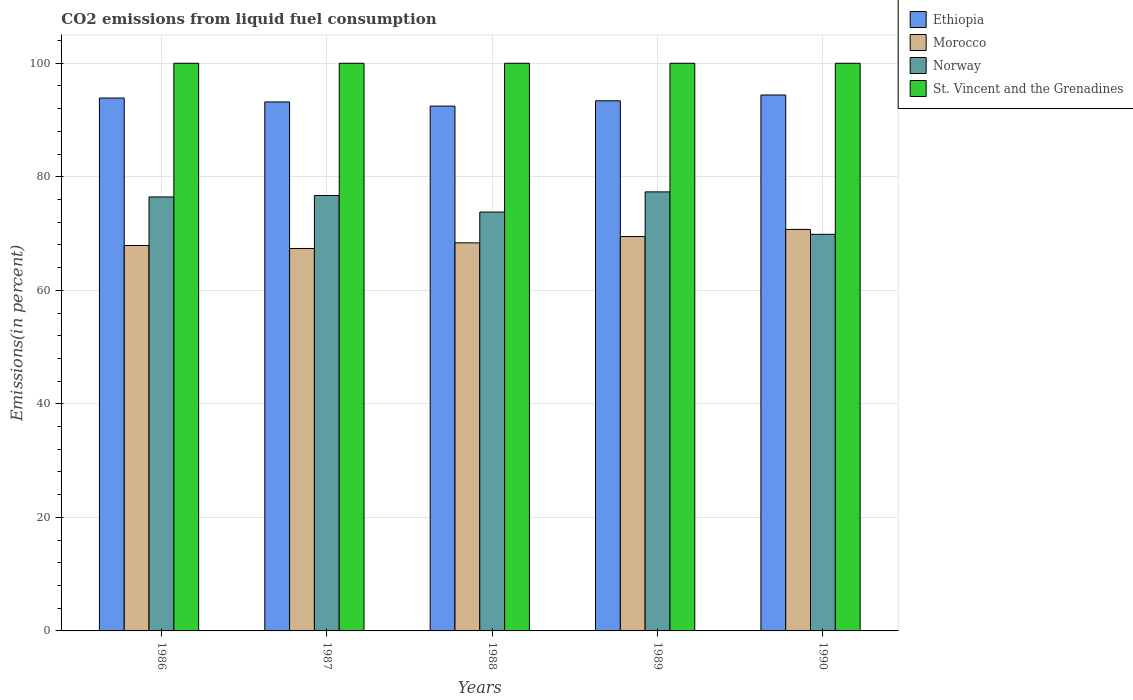How many different coloured bars are there?
Provide a short and direct response. 4. How many groups of bars are there?
Your answer should be very brief. 5. Are the number of bars per tick equal to the number of legend labels?
Ensure brevity in your answer.  Yes. Are the number of bars on each tick of the X-axis equal?
Offer a terse response. Yes. How many bars are there on the 3rd tick from the left?
Give a very brief answer. 4. How many bars are there on the 4th tick from the right?
Your answer should be compact. 4. What is the label of the 5th group of bars from the left?
Keep it short and to the point. 1990. In how many cases, is the number of bars for a given year not equal to the number of legend labels?
Offer a very short reply. 0. What is the total CO2 emitted in St. Vincent and the Grenadines in 1990?
Give a very brief answer. 100. Across all years, what is the maximum total CO2 emitted in St. Vincent and the Grenadines?
Provide a succinct answer. 100. Across all years, what is the minimum total CO2 emitted in Ethiopia?
Make the answer very short. 92.46. What is the total total CO2 emitted in Norway in the graph?
Give a very brief answer. 374.15. What is the difference between the total CO2 emitted in Norway in 1989 and that in 1990?
Your answer should be very brief. 7.47. What is the difference between the total CO2 emitted in Ethiopia in 1986 and the total CO2 emitted in Norway in 1988?
Offer a very short reply. 20.09. What is the average total CO2 emitted in Morocco per year?
Ensure brevity in your answer.  68.77. In the year 1987, what is the difference between the total CO2 emitted in Ethiopia and total CO2 emitted in Norway?
Your answer should be compact. 16.48. In how many years, is the total CO2 emitted in Morocco greater than 52 %?
Your response must be concise. 5. What is the ratio of the total CO2 emitted in Ethiopia in 1988 to that in 1990?
Provide a succinct answer. 0.98. Is the total CO2 emitted in Norway in 1987 less than that in 1988?
Provide a succinct answer. No. What is the difference between the highest and the second highest total CO2 emitted in Norway?
Make the answer very short. 0.64. What is the difference between the highest and the lowest total CO2 emitted in Norway?
Ensure brevity in your answer.  7.47. Is it the case that in every year, the sum of the total CO2 emitted in St. Vincent and the Grenadines and total CO2 emitted in Morocco is greater than the sum of total CO2 emitted in Ethiopia and total CO2 emitted in Norway?
Ensure brevity in your answer.  Yes. What does the 2nd bar from the left in 1988 represents?
Keep it short and to the point. Morocco. Is it the case that in every year, the sum of the total CO2 emitted in Ethiopia and total CO2 emitted in Norway is greater than the total CO2 emitted in St. Vincent and the Grenadines?
Offer a terse response. Yes. How many bars are there?
Offer a terse response. 20. Are all the bars in the graph horizontal?
Make the answer very short. No. How many years are there in the graph?
Give a very brief answer. 5. Does the graph contain grids?
Your response must be concise. Yes. How many legend labels are there?
Your answer should be very brief. 4. How are the legend labels stacked?
Give a very brief answer. Vertical. What is the title of the graph?
Your answer should be compact. CO2 emissions from liquid fuel consumption. What is the label or title of the Y-axis?
Ensure brevity in your answer.  Emissions(in percent). What is the Emissions(in percent) of Ethiopia in 1986?
Keep it short and to the point. 93.87. What is the Emissions(in percent) in Morocco in 1986?
Your answer should be very brief. 67.9. What is the Emissions(in percent) in Norway in 1986?
Your response must be concise. 76.45. What is the Emissions(in percent) of St. Vincent and the Grenadines in 1986?
Keep it short and to the point. 100. What is the Emissions(in percent) of Ethiopia in 1987?
Offer a very short reply. 93.18. What is the Emissions(in percent) of Morocco in 1987?
Offer a very short reply. 67.37. What is the Emissions(in percent) in Norway in 1987?
Provide a succinct answer. 76.7. What is the Emissions(in percent) of St. Vincent and the Grenadines in 1987?
Provide a short and direct response. 100. What is the Emissions(in percent) of Ethiopia in 1988?
Provide a short and direct response. 92.46. What is the Emissions(in percent) in Morocco in 1988?
Offer a very short reply. 68.36. What is the Emissions(in percent) of Norway in 1988?
Ensure brevity in your answer.  73.79. What is the Emissions(in percent) in St. Vincent and the Grenadines in 1988?
Offer a very short reply. 100. What is the Emissions(in percent) of Ethiopia in 1989?
Your answer should be compact. 93.39. What is the Emissions(in percent) of Morocco in 1989?
Your answer should be compact. 69.47. What is the Emissions(in percent) of Norway in 1989?
Give a very brief answer. 77.34. What is the Emissions(in percent) in St. Vincent and the Grenadines in 1989?
Keep it short and to the point. 100. What is the Emissions(in percent) of Ethiopia in 1990?
Your response must be concise. 94.41. What is the Emissions(in percent) in Morocco in 1990?
Provide a short and direct response. 70.73. What is the Emissions(in percent) of Norway in 1990?
Ensure brevity in your answer.  69.87. Across all years, what is the maximum Emissions(in percent) in Ethiopia?
Offer a terse response. 94.41. Across all years, what is the maximum Emissions(in percent) in Morocco?
Keep it short and to the point. 70.73. Across all years, what is the maximum Emissions(in percent) of Norway?
Provide a short and direct response. 77.34. Across all years, what is the maximum Emissions(in percent) of St. Vincent and the Grenadines?
Your answer should be compact. 100. Across all years, what is the minimum Emissions(in percent) of Ethiopia?
Your response must be concise. 92.46. Across all years, what is the minimum Emissions(in percent) of Morocco?
Your answer should be compact. 67.37. Across all years, what is the minimum Emissions(in percent) in Norway?
Give a very brief answer. 69.87. What is the total Emissions(in percent) in Ethiopia in the graph?
Provide a succinct answer. 467.31. What is the total Emissions(in percent) of Morocco in the graph?
Your response must be concise. 343.84. What is the total Emissions(in percent) in Norway in the graph?
Ensure brevity in your answer.  374.15. What is the difference between the Emissions(in percent) of Ethiopia in 1986 and that in 1987?
Make the answer very short. 0.69. What is the difference between the Emissions(in percent) in Morocco in 1986 and that in 1987?
Provide a short and direct response. 0.53. What is the difference between the Emissions(in percent) of Norway in 1986 and that in 1987?
Keep it short and to the point. -0.25. What is the difference between the Emissions(in percent) of St. Vincent and the Grenadines in 1986 and that in 1987?
Provide a succinct answer. 0. What is the difference between the Emissions(in percent) of Ethiopia in 1986 and that in 1988?
Offer a very short reply. 1.42. What is the difference between the Emissions(in percent) in Morocco in 1986 and that in 1988?
Provide a short and direct response. -0.47. What is the difference between the Emissions(in percent) of Norway in 1986 and that in 1988?
Give a very brief answer. 2.66. What is the difference between the Emissions(in percent) of Ethiopia in 1986 and that in 1989?
Make the answer very short. 0.49. What is the difference between the Emissions(in percent) of Morocco in 1986 and that in 1989?
Give a very brief answer. -1.58. What is the difference between the Emissions(in percent) of Norway in 1986 and that in 1989?
Make the answer very short. -0.89. What is the difference between the Emissions(in percent) in St. Vincent and the Grenadines in 1986 and that in 1989?
Make the answer very short. 0. What is the difference between the Emissions(in percent) in Ethiopia in 1986 and that in 1990?
Make the answer very short. -0.54. What is the difference between the Emissions(in percent) of Morocco in 1986 and that in 1990?
Offer a terse response. -2.84. What is the difference between the Emissions(in percent) of Norway in 1986 and that in 1990?
Keep it short and to the point. 6.58. What is the difference between the Emissions(in percent) in Ethiopia in 1987 and that in 1988?
Offer a terse response. 0.73. What is the difference between the Emissions(in percent) in Morocco in 1987 and that in 1988?
Offer a very short reply. -0.99. What is the difference between the Emissions(in percent) in Norway in 1987 and that in 1988?
Give a very brief answer. 2.91. What is the difference between the Emissions(in percent) in St. Vincent and the Grenadines in 1987 and that in 1988?
Make the answer very short. 0. What is the difference between the Emissions(in percent) in Ethiopia in 1987 and that in 1989?
Ensure brevity in your answer.  -0.2. What is the difference between the Emissions(in percent) of Morocco in 1987 and that in 1989?
Your response must be concise. -2.1. What is the difference between the Emissions(in percent) of Norway in 1987 and that in 1989?
Keep it short and to the point. -0.64. What is the difference between the Emissions(in percent) of St. Vincent and the Grenadines in 1987 and that in 1989?
Provide a succinct answer. 0. What is the difference between the Emissions(in percent) in Ethiopia in 1987 and that in 1990?
Keep it short and to the point. -1.23. What is the difference between the Emissions(in percent) of Morocco in 1987 and that in 1990?
Your answer should be very brief. -3.36. What is the difference between the Emissions(in percent) in Norway in 1987 and that in 1990?
Offer a very short reply. 6.83. What is the difference between the Emissions(in percent) in St. Vincent and the Grenadines in 1987 and that in 1990?
Offer a very short reply. 0. What is the difference between the Emissions(in percent) of Ethiopia in 1988 and that in 1989?
Your answer should be very brief. -0.93. What is the difference between the Emissions(in percent) of Morocco in 1988 and that in 1989?
Provide a short and direct response. -1.11. What is the difference between the Emissions(in percent) of Norway in 1988 and that in 1989?
Your answer should be very brief. -3.55. What is the difference between the Emissions(in percent) in St. Vincent and the Grenadines in 1988 and that in 1989?
Provide a succinct answer. 0. What is the difference between the Emissions(in percent) of Ethiopia in 1988 and that in 1990?
Your response must be concise. -1.96. What is the difference between the Emissions(in percent) in Morocco in 1988 and that in 1990?
Keep it short and to the point. -2.37. What is the difference between the Emissions(in percent) of Norway in 1988 and that in 1990?
Give a very brief answer. 3.92. What is the difference between the Emissions(in percent) in Ethiopia in 1989 and that in 1990?
Offer a very short reply. -1.03. What is the difference between the Emissions(in percent) of Morocco in 1989 and that in 1990?
Offer a terse response. -1.26. What is the difference between the Emissions(in percent) in Norway in 1989 and that in 1990?
Your response must be concise. 7.47. What is the difference between the Emissions(in percent) of Ethiopia in 1986 and the Emissions(in percent) of Morocco in 1987?
Keep it short and to the point. 26.5. What is the difference between the Emissions(in percent) in Ethiopia in 1986 and the Emissions(in percent) in Norway in 1987?
Offer a very short reply. 17.17. What is the difference between the Emissions(in percent) of Ethiopia in 1986 and the Emissions(in percent) of St. Vincent and the Grenadines in 1987?
Provide a short and direct response. -6.13. What is the difference between the Emissions(in percent) of Morocco in 1986 and the Emissions(in percent) of Norway in 1987?
Provide a succinct answer. -8.8. What is the difference between the Emissions(in percent) of Morocco in 1986 and the Emissions(in percent) of St. Vincent and the Grenadines in 1987?
Your answer should be compact. -32.1. What is the difference between the Emissions(in percent) in Norway in 1986 and the Emissions(in percent) in St. Vincent and the Grenadines in 1987?
Provide a short and direct response. -23.55. What is the difference between the Emissions(in percent) in Ethiopia in 1986 and the Emissions(in percent) in Morocco in 1988?
Offer a terse response. 25.51. What is the difference between the Emissions(in percent) in Ethiopia in 1986 and the Emissions(in percent) in Norway in 1988?
Ensure brevity in your answer.  20.09. What is the difference between the Emissions(in percent) of Ethiopia in 1986 and the Emissions(in percent) of St. Vincent and the Grenadines in 1988?
Offer a very short reply. -6.13. What is the difference between the Emissions(in percent) of Morocco in 1986 and the Emissions(in percent) of Norway in 1988?
Your answer should be very brief. -5.89. What is the difference between the Emissions(in percent) of Morocco in 1986 and the Emissions(in percent) of St. Vincent and the Grenadines in 1988?
Provide a short and direct response. -32.1. What is the difference between the Emissions(in percent) in Norway in 1986 and the Emissions(in percent) in St. Vincent and the Grenadines in 1988?
Make the answer very short. -23.55. What is the difference between the Emissions(in percent) of Ethiopia in 1986 and the Emissions(in percent) of Morocco in 1989?
Provide a succinct answer. 24.4. What is the difference between the Emissions(in percent) in Ethiopia in 1986 and the Emissions(in percent) in Norway in 1989?
Your answer should be very brief. 16.53. What is the difference between the Emissions(in percent) of Ethiopia in 1986 and the Emissions(in percent) of St. Vincent and the Grenadines in 1989?
Provide a short and direct response. -6.13. What is the difference between the Emissions(in percent) of Morocco in 1986 and the Emissions(in percent) of Norway in 1989?
Make the answer very short. -9.44. What is the difference between the Emissions(in percent) of Morocco in 1986 and the Emissions(in percent) of St. Vincent and the Grenadines in 1989?
Your answer should be compact. -32.1. What is the difference between the Emissions(in percent) of Norway in 1986 and the Emissions(in percent) of St. Vincent and the Grenadines in 1989?
Your answer should be very brief. -23.55. What is the difference between the Emissions(in percent) in Ethiopia in 1986 and the Emissions(in percent) in Morocco in 1990?
Your answer should be very brief. 23.14. What is the difference between the Emissions(in percent) of Ethiopia in 1986 and the Emissions(in percent) of Norway in 1990?
Ensure brevity in your answer.  24.01. What is the difference between the Emissions(in percent) of Ethiopia in 1986 and the Emissions(in percent) of St. Vincent and the Grenadines in 1990?
Offer a terse response. -6.13. What is the difference between the Emissions(in percent) in Morocco in 1986 and the Emissions(in percent) in Norway in 1990?
Provide a succinct answer. -1.97. What is the difference between the Emissions(in percent) of Morocco in 1986 and the Emissions(in percent) of St. Vincent and the Grenadines in 1990?
Your response must be concise. -32.1. What is the difference between the Emissions(in percent) of Norway in 1986 and the Emissions(in percent) of St. Vincent and the Grenadines in 1990?
Offer a very short reply. -23.55. What is the difference between the Emissions(in percent) in Ethiopia in 1987 and the Emissions(in percent) in Morocco in 1988?
Your response must be concise. 24.82. What is the difference between the Emissions(in percent) of Ethiopia in 1987 and the Emissions(in percent) of Norway in 1988?
Your answer should be very brief. 19.39. What is the difference between the Emissions(in percent) of Ethiopia in 1987 and the Emissions(in percent) of St. Vincent and the Grenadines in 1988?
Your answer should be compact. -6.82. What is the difference between the Emissions(in percent) in Morocco in 1987 and the Emissions(in percent) in Norway in 1988?
Provide a succinct answer. -6.42. What is the difference between the Emissions(in percent) in Morocco in 1987 and the Emissions(in percent) in St. Vincent and the Grenadines in 1988?
Make the answer very short. -32.63. What is the difference between the Emissions(in percent) in Norway in 1987 and the Emissions(in percent) in St. Vincent and the Grenadines in 1988?
Provide a short and direct response. -23.3. What is the difference between the Emissions(in percent) in Ethiopia in 1987 and the Emissions(in percent) in Morocco in 1989?
Keep it short and to the point. 23.71. What is the difference between the Emissions(in percent) of Ethiopia in 1987 and the Emissions(in percent) of Norway in 1989?
Make the answer very short. 15.84. What is the difference between the Emissions(in percent) of Ethiopia in 1987 and the Emissions(in percent) of St. Vincent and the Grenadines in 1989?
Your answer should be compact. -6.82. What is the difference between the Emissions(in percent) of Morocco in 1987 and the Emissions(in percent) of Norway in 1989?
Provide a succinct answer. -9.97. What is the difference between the Emissions(in percent) of Morocco in 1987 and the Emissions(in percent) of St. Vincent and the Grenadines in 1989?
Your answer should be very brief. -32.63. What is the difference between the Emissions(in percent) of Norway in 1987 and the Emissions(in percent) of St. Vincent and the Grenadines in 1989?
Your answer should be compact. -23.3. What is the difference between the Emissions(in percent) in Ethiopia in 1987 and the Emissions(in percent) in Morocco in 1990?
Ensure brevity in your answer.  22.45. What is the difference between the Emissions(in percent) of Ethiopia in 1987 and the Emissions(in percent) of Norway in 1990?
Your response must be concise. 23.31. What is the difference between the Emissions(in percent) of Ethiopia in 1987 and the Emissions(in percent) of St. Vincent and the Grenadines in 1990?
Give a very brief answer. -6.82. What is the difference between the Emissions(in percent) in Morocco in 1987 and the Emissions(in percent) in Norway in 1990?
Your answer should be compact. -2.5. What is the difference between the Emissions(in percent) of Morocco in 1987 and the Emissions(in percent) of St. Vincent and the Grenadines in 1990?
Keep it short and to the point. -32.63. What is the difference between the Emissions(in percent) of Norway in 1987 and the Emissions(in percent) of St. Vincent and the Grenadines in 1990?
Make the answer very short. -23.3. What is the difference between the Emissions(in percent) in Ethiopia in 1988 and the Emissions(in percent) in Morocco in 1989?
Give a very brief answer. 22.98. What is the difference between the Emissions(in percent) in Ethiopia in 1988 and the Emissions(in percent) in Norway in 1989?
Your response must be concise. 15.11. What is the difference between the Emissions(in percent) in Ethiopia in 1988 and the Emissions(in percent) in St. Vincent and the Grenadines in 1989?
Make the answer very short. -7.54. What is the difference between the Emissions(in percent) of Morocco in 1988 and the Emissions(in percent) of Norway in 1989?
Ensure brevity in your answer.  -8.98. What is the difference between the Emissions(in percent) of Morocco in 1988 and the Emissions(in percent) of St. Vincent and the Grenadines in 1989?
Your response must be concise. -31.64. What is the difference between the Emissions(in percent) in Norway in 1988 and the Emissions(in percent) in St. Vincent and the Grenadines in 1989?
Your response must be concise. -26.21. What is the difference between the Emissions(in percent) of Ethiopia in 1988 and the Emissions(in percent) of Morocco in 1990?
Keep it short and to the point. 21.72. What is the difference between the Emissions(in percent) of Ethiopia in 1988 and the Emissions(in percent) of Norway in 1990?
Ensure brevity in your answer.  22.59. What is the difference between the Emissions(in percent) of Ethiopia in 1988 and the Emissions(in percent) of St. Vincent and the Grenadines in 1990?
Ensure brevity in your answer.  -7.54. What is the difference between the Emissions(in percent) in Morocco in 1988 and the Emissions(in percent) in Norway in 1990?
Offer a very short reply. -1.5. What is the difference between the Emissions(in percent) in Morocco in 1988 and the Emissions(in percent) in St. Vincent and the Grenadines in 1990?
Your answer should be very brief. -31.64. What is the difference between the Emissions(in percent) in Norway in 1988 and the Emissions(in percent) in St. Vincent and the Grenadines in 1990?
Your answer should be very brief. -26.21. What is the difference between the Emissions(in percent) in Ethiopia in 1989 and the Emissions(in percent) in Morocco in 1990?
Keep it short and to the point. 22.65. What is the difference between the Emissions(in percent) of Ethiopia in 1989 and the Emissions(in percent) of Norway in 1990?
Give a very brief answer. 23.52. What is the difference between the Emissions(in percent) of Ethiopia in 1989 and the Emissions(in percent) of St. Vincent and the Grenadines in 1990?
Offer a very short reply. -6.61. What is the difference between the Emissions(in percent) of Morocco in 1989 and the Emissions(in percent) of Norway in 1990?
Keep it short and to the point. -0.4. What is the difference between the Emissions(in percent) in Morocco in 1989 and the Emissions(in percent) in St. Vincent and the Grenadines in 1990?
Your answer should be very brief. -30.53. What is the difference between the Emissions(in percent) of Norway in 1989 and the Emissions(in percent) of St. Vincent and the Grenadines in 1990?
Your response must be concise. -22.66. What is the average Emissions(in percent) of Ethiopia per year?
Offer a terse response. 93.46. What is the average Emissions(in percent) in Morocco per year?
Your answer should be very brief. 68.77. What is the average Emissions(in percent) of Norway per year?
Provide a succinct answer. 74.83. In the year 1986, what is the difference between the Emissions(in percent) in Ethiopia and Emissions(in percent) in Morocco?
Give a very brief answer. 25.98. In the year 1986, what is the difference between the Emissions(in percent) in Ethiopia and Emissions(in percent) in Norway?
Offer a terse response. 17.42. In the year 1986, what is the difference between the Emissions(in percent) of Ethiopia and Emissions(in percent) of St. Vincent and the Grenadines?
Your response must be concise. -6.13. In the year 1986, what is the difference between the Emissions(in percent) of Morocco and Emissions(in percent) of Norway?
Your answer should be compact. -8.55. In the year 1986, what is the difference between the Emissions(in percent) of Morocco and Emissions(in percent) of St. Vincent and the Grenadines?
Make the answer very short. -32.1. In the year 1986, what is the difference between the Emissions(in percent) of Norway and Emissions(in percent) of St. Vincent and the Grenadines?
Keep it short and to the point. -23.55. In the year 1987, what is the difference between the Emissions(in percent) in Ethiopia and Emissions(in percent) in Morocco?
Provide a succinct answer. 25.81. In the year 1987, what is the difference between the Emissions(in percent) in Ethiopia and Emissions(in percent) in Norway?
Give a very brief answer. 16.48. In the year 1987, what is the difference between the Emissions(in percent) of Ethiopia and Emissions(in percent) of St. Vincent and the Grenadines?
Make the answer very short. -6.82. In the year 1987, what is the difference between the Emissions(in percent) in Morocco and Emissions(in percent) in Norway?
Provide a short and direct response. -9.33. In the year 1987, what is the difference between the Emissions(in percent) of Morocco and Emissions(in percent) of St. Vincent and the Grenadines?
Make the answer very short. -32.63. In the year 1987, what is the difference between the Emissions(in percent) in Norway and Emissions(in percent) in St. Vincent and the Grenadines?
Your answer should be compact. -23.3. In the year 1988, what is the difference between the Emissions(in percent) of Ethiopia and Emissions(in percent) of Morocco?
Give a very brief answer. 24.09. In the year 1988, what is the difference between the Emissions(in percent) of Ethiopia and Emissions(in percent) of Norway?
Give a very brief answer. 18.67. In the year 1988, what is the difference between the Emissions(in percent) in Ethiopia and Emissions(in percent) in St. Vincent and the Grenadines?
Your response must be concise. -7.54. In the year 1988, what is the difference between the Emissions(in percent) in Morocco and Emissions(in percent) in Norway?
Make the answer very short. -5.42. In the year 1988, what is the difference between the Emissions(in percent) in Morocco and Emissions(in percent) in St. Vincent and the Grenadines?
Make the answer very short. -31.64. In the year 1988, what is the difference between the Emissions(in percent) of Norway and Emissions(in percent) of St. Vincent and the Grenadines?
Provide a short and direct response. -26.21. In the year 1989, what is the difference between the Emissions(in percent) of Ethiopia and Emissions(in percent) of Morocco?
Your response must be concise. 23.91. In the year 1989, what is the difference between the Emissions(in percent) in Ethiopia and Emissions(in percent) in Norway?
Your answer should be very brief. 16.04. In the year 1989, what is the difference between the Emissions(in percent) in Ethiopia and Emissions(in percent) in St. Vincent and the Grenadines?
Give a very brief answer. -6.61. In the year 1989, what is the difference between the Emissions(in percent) of Morocco and Emissions(in percent) of Norway?
Your answer should be compact. -7.87. In the year 1989, what is the difference between the Emissions(in percent) of Morocco and Emissions(in percent) of St. Vincent and the Grenadines?
Your response must be concise. -30.53. In the year 1989, what is the difference between the Emissions(in percent) in Norway and Emissions(in percent) in St. Vincent and the Grenadines?
Your response must be concise. -22.66. In the year 1990, what is the difference between the Emissions(in percent) in Ethiopia and Emissions(in percent) in Morocco?
Provide a short and direct response. 23.68. In the year 1990, what is the difference between the Emissions(in percent) in Ethiopia and Emissions(in percent) in Norway?
Your answer should be compact. 24.54. In the year 1990, what is the difference between the Emissions(in percent) in Ethiopia and Emissions(in percent) in St. Vincent and the Grenadines?
Provide a succinct answer. -5.59. In the year 1990, what is the difference between the Emissions(in percent) in Morocco and Emissions(in percent) in Norway?
Your answer should be compact. 0.86. In the year 1990, what is the difference between the Emissions(in percent) in Morocco and Emissions(in percent) in St. Vincent and the Grenadines?
Your answer should be compact. -29.27. In the year 1990, what is the difference between the Emissions(in percent) in Norway and Emissions(in percent) in St. Vincent and the Grenadines?
Make the answer very short. -30.13. What is the ratio of the Emissions(in percent) in Ethiopia in 1986 to that in 1987?
Offer a terse response. 1.01. What is the ratio of the Emissions(in percent) in Morocco in 1986 to that in 1987?
Offer a very short reply. 1.01. What is the ratio of the Emissions(in percent) of Norway in 1986 to that in 1987?
Offer a terse response. 1. What is the ratio of the Emissions(in percent) in St. Vincent and the Grenadines in 1986 to that in 1987?
Offer a terse response. 1. What is the ratio of the Emissions(in percent) of Ethiopia in 1986 to that in 1988?
Your answer should be very brief. 1.02. What is the ratio of the Emissions(in percent) of Morocco in 1986 to that in 1988?
Ensure brevity in your answer.  0.99. What is the ratio of the Emissions(in percent) in Norway in 1986 to that in 1988?
Your response must be concise. 1.04. What is the ratio of the Emissions(in percent) of Morocco in 1986 to that in 1989?
Make the answer very short. 0.98. What is the ratio of the Emissions(in percent) of Ethiopia in 1986 to that in 1990?
Offer a very short reply. 0.99. What is the ratio of the Emissions(in percent) in Morocco in 1986 to that in 1990?
Provide a succinct answer. 0.96. What is the ratio of the Emissions(in percent) of Norway in 1986 to that in 1990?
Your answer should be very brief. 1.09. What is the ratio of the Emissions(in percent) of Ethiopia in 1987 to that in 1988?
Provide a short and direct response. 1.01. What is the ratio of the Emissions(in percent) of Morocco in 1987 to that in 1988?
Keep it short and to the point. 0.99. What is the ratio of the Emissions(in percent) in Norway in 1987 to that in 1988?
Offer a very short reply. 1.04. What is the ratio of the Emissions(in percent) of Ethiopia in 1987 to that in 1989?
Your answer should be very brief. 1. What is the ratio of the Emissions(in percent) of Morocco in 1987 to that in 1989?
Your response must be concise. 0.97. What is the ratio of the Emissions(in percent) in Norway in 1987 to that in 1989?
Provide a succinct answer. 0.99. What is the ratio of the Emissions(in percent) of St. Vincent and the Grenadines in 1987 to that in 1989?
Give a very brief answer. 1. What is the ratio of the Emissions(in percent) in Ethiopia in 1987 to that in 1990?
Offer a very short reply. 0.99. What is the ratio of the Emissions(in percent) in Morocco in 1987 to that in 1990?
Ensure brevity in your answer.  0.95. What is the ratio of the Emissions(in percent) of Norway in 1987 to that in 1990?
Offer a very short reply. 1.1. What is the ratio of the Emissions(in percent) in Morocco in 1988 to that in 1989?
Make the answer very short. 0.98. What is the ratio of the Emissions(in percent) in Norway in 1988 to that in 1989?
Give a very brief answer. 0.95. What is the ratio of the Emissions(in percent) in St. Vincent and the Grenadines in 1988 to that in 1989?
Make the answer very short. 1. What is the ratio of the Emissions(in percent) in Ethiopia in 1988 to that in 1990?
Keep it short and to the point. 0.98. What is the ratio of the Emissions(in percent) in Morocco in 1988 to that in 1990?
Your answer should be compact. 0.97. What is the ratio of the Emissions(in percent) in Norway in 1988 to that in 1990?
Offer a terse response. 1.06. What is the ratio of the Emissions(in percent) in Ethiopia in 1989 to that in 1990?
Your response must be concise. 0.99. What is the ratio of the Emissions(in percent) of Morocco in 1989 to that in 1990?
Your answer should be compact. 0.98. What is the ratio of the Emissions(in percent) in Norway in 1989 to that in 1990?
Your answer should be very brief. 1.11. What is the difference between the highest and the second highest Emissions(in percent) in Ethiopia?
Give a very brief answer. 0.54. What is the difference between the highest and the second highest Emissions(in percent) in Morocco?
Offer a terse response. 1.26. What is the difference between the highest and the second highest Emissions(in percent) of Norway?
Offer a very short reply. 0.64. What is the difference between the highest and the second highest Emissions(in percent) in St. Vincent and the Grenadines?
Make the answer very short. 0. What is the difference between the highest and the lowest Emissions(in percent) in Ethiopia?
Keep it short and to the point. 1.96. What is the difference between the highest and the lowest Emissions(in percent) in Morocco?
Your answer should be very brief. 3.36. What is the difference between the highest and the lowest Emissions(in percent) in Norway?
Make the answer very short. 7.47. 